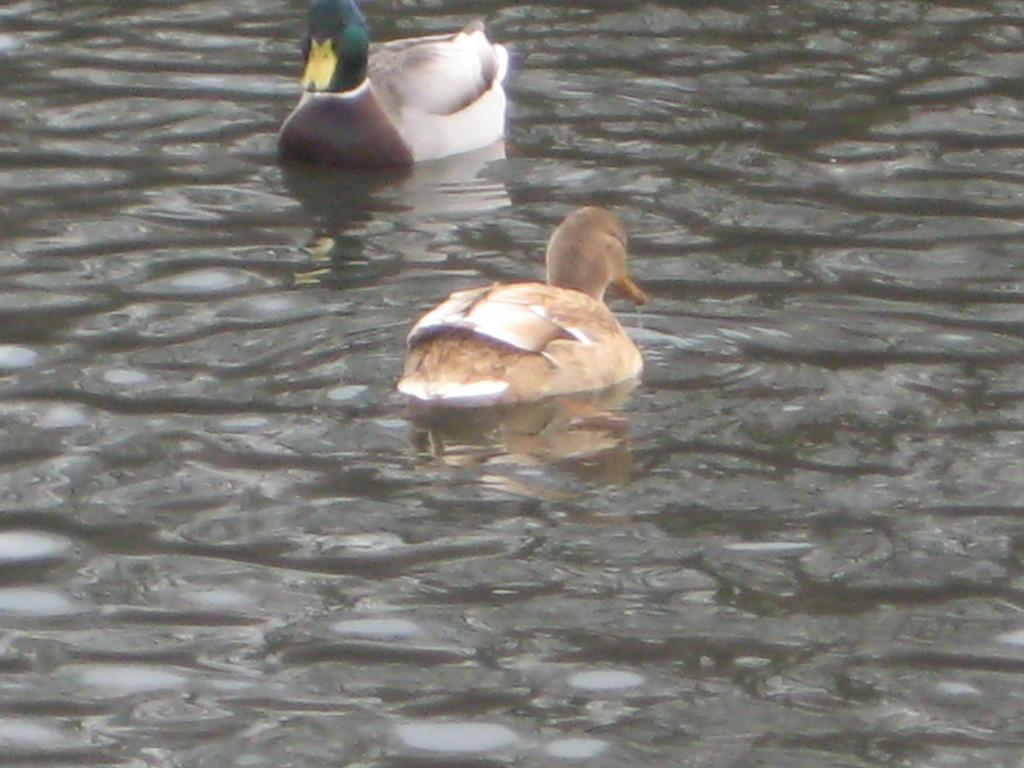What animals are present in the image? There are two ducks in the image. Where are the ducks located? The ducks are in the water. How does the earthquake affect the ducks in the image? There is no earthquake present in the image, so its effect on the ducks cannot be determined. 